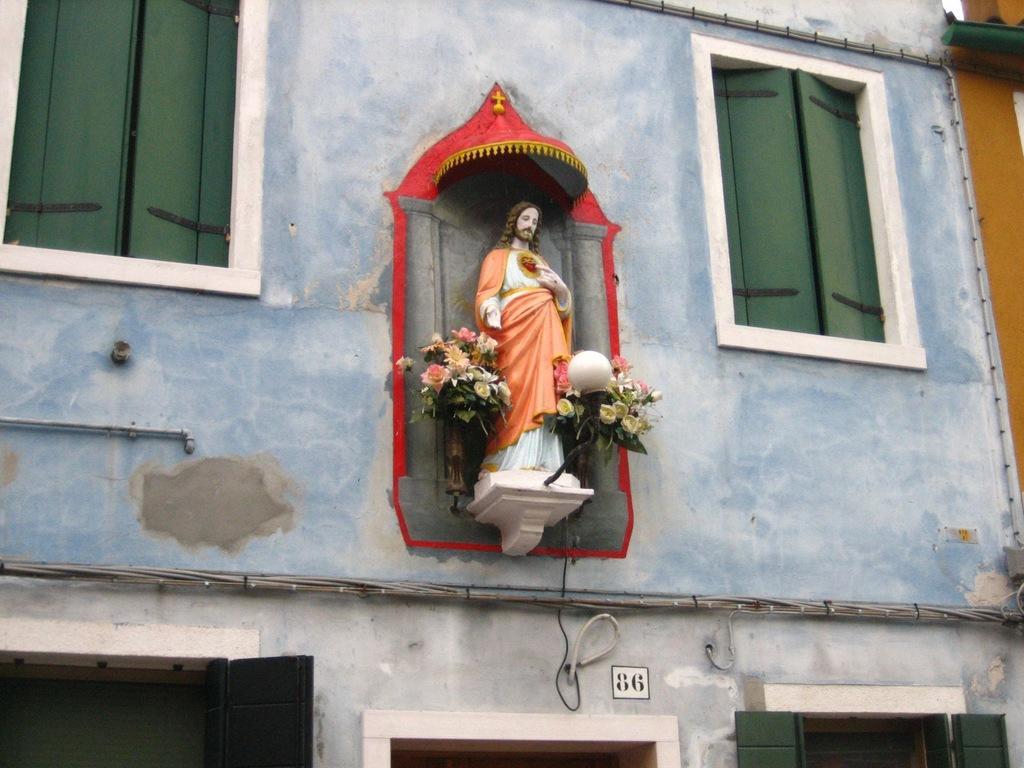How would you summarize this image in a sentence or two? Here I can see a building along with the windows. In the middle of this image I can see an Idol which is attached to the wall. On both sides of this idol I can see some artificial flowers. 